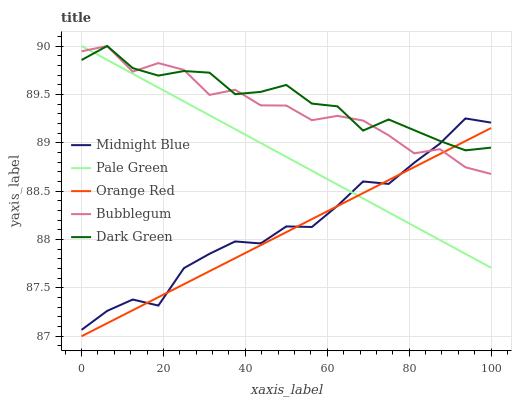Does Orange Red have the minimum area under the curve?
Answer yes or no. Yes. Does Dark Green have the maximum area under the curve?
Answer yes or no. Yes. Does Pale Green have the minimum area under the curve?
Answer yes or no. No. Does Pale Green have the maximum area under the curve?
Answer yes or no. No. Is Pale Green the smoothest?
Answer yes or no. Yes. Is Bubblegum the roughest?
Answer yes or no. Yes. Is Midnight Blue the smoothest?
Answer yes or no. No. Is Midnight Blue the roughest?
Answer yes or no. No. Does Orange Red have the lowest value?
Answer yes or no. Yes. Does Pale Green have the lowest value?
Answer yes or no. No. Does Bubblegum have the highest value?
Answer yes or no. Yes. Does Midnight Blue have the highest value?
Answer yes or no. No. Does Pale Green intersect Midnight Blue?
Answer yes or no. Yes. Is Pale Green less than Midnight Blue?
Answer yes or no. No. Is Pale Green greater than Midnight Blue?
Answer yes or no. No. 